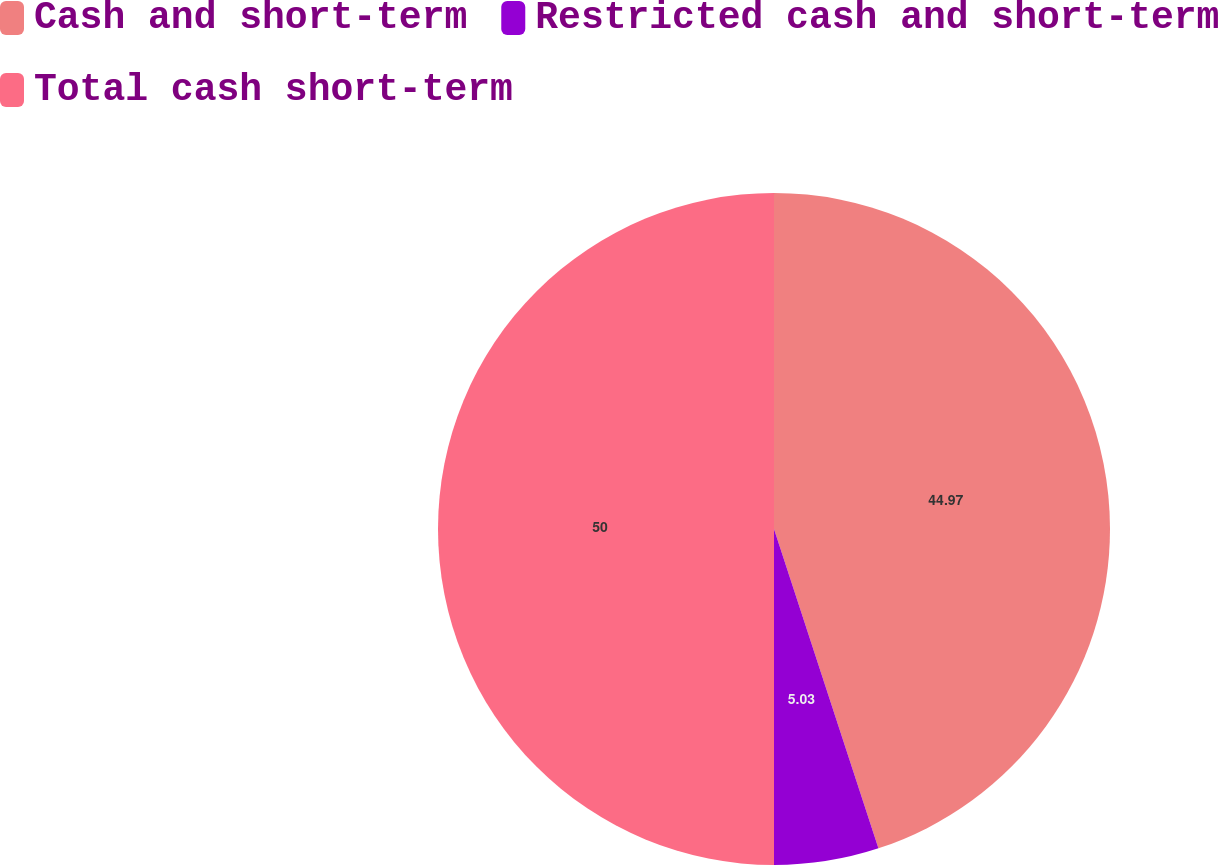Convert chart. <chart><loc_0><loc_0><loc_500><loc_500><pie_chart><fcel>Cash and short-term<fcel>Restricted cash and short-term<fcel>Total cash short-term<nl><fcel>44.97%<fcel>5.03%<fcel>50.0%<nl></chart> 